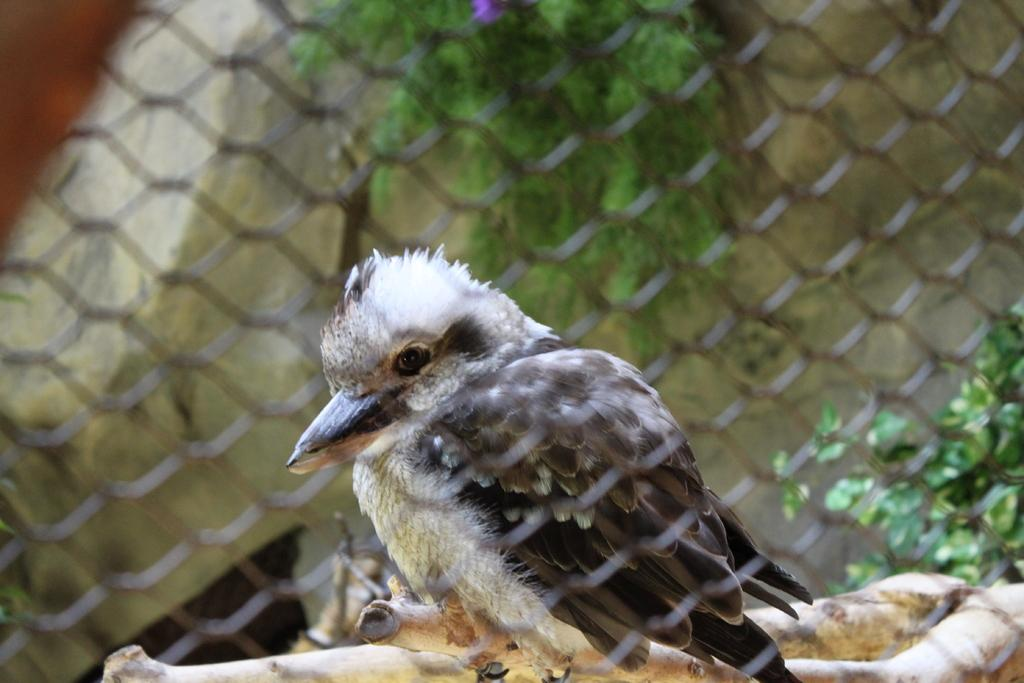What is located in the front of the image? There is a net in the front of the image. What is the bird doing in the image? The bird is standing on a wooden block in the image. What type of vegetation can be seen in the image? There are plants visible in the image. What type of territory is the bird claiming in the image? There is no indication of the bird claiming any territory in the image. What kind of test is the bird taking in the image? There is no test present in the image; the bird is simply standing on a wooden block. 